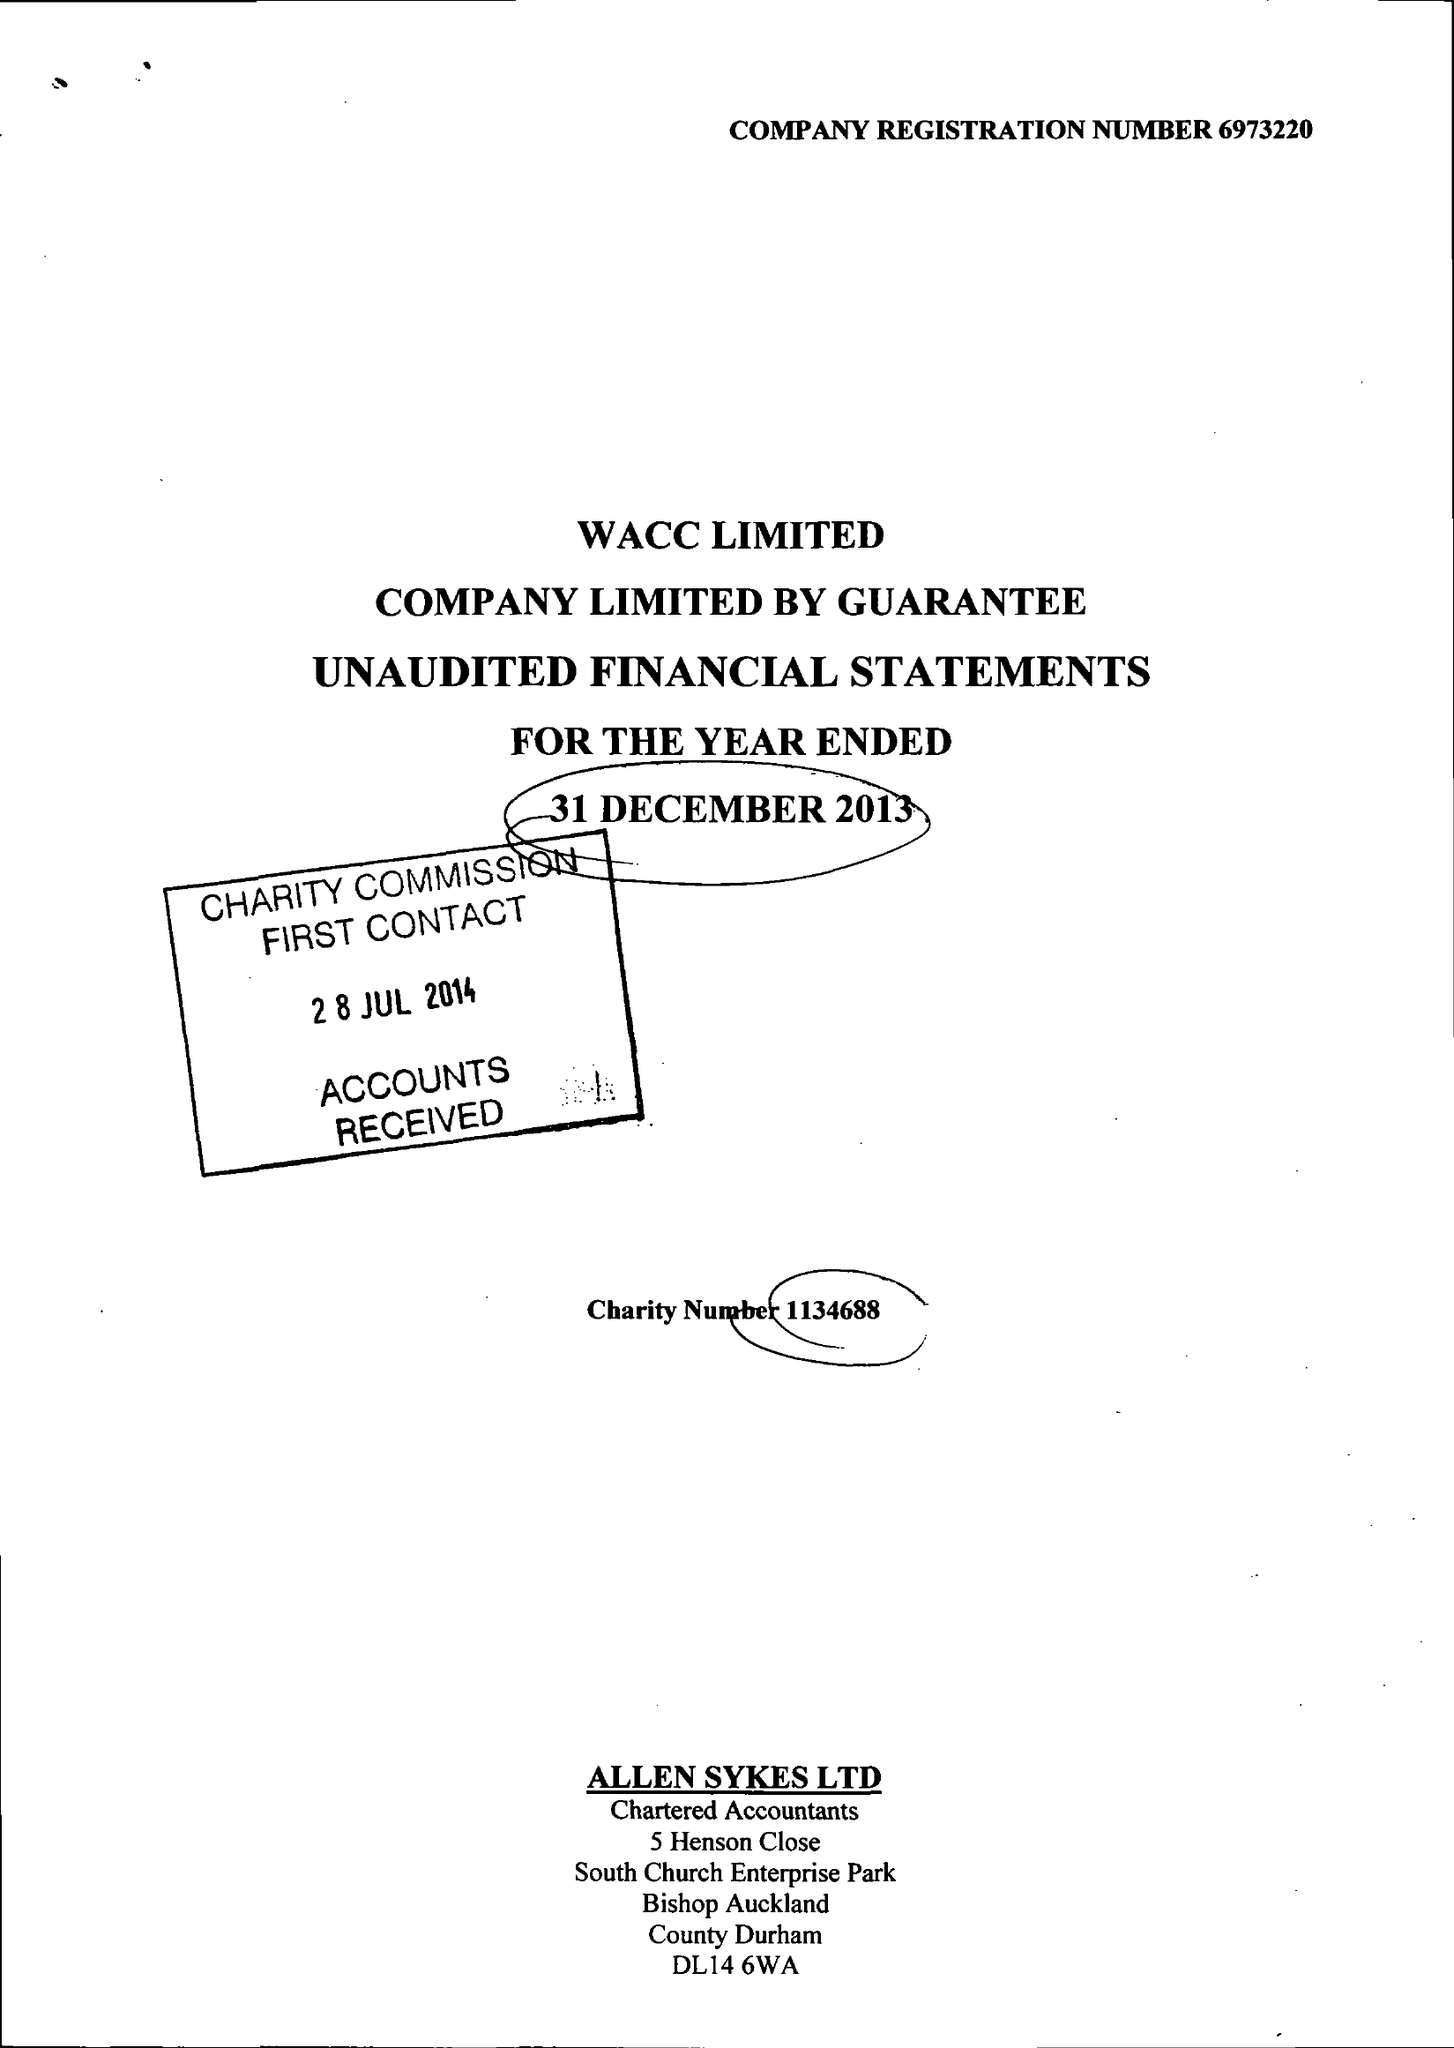What is the value for the address__street_line?
Answer the question using a single word or phrase. None 